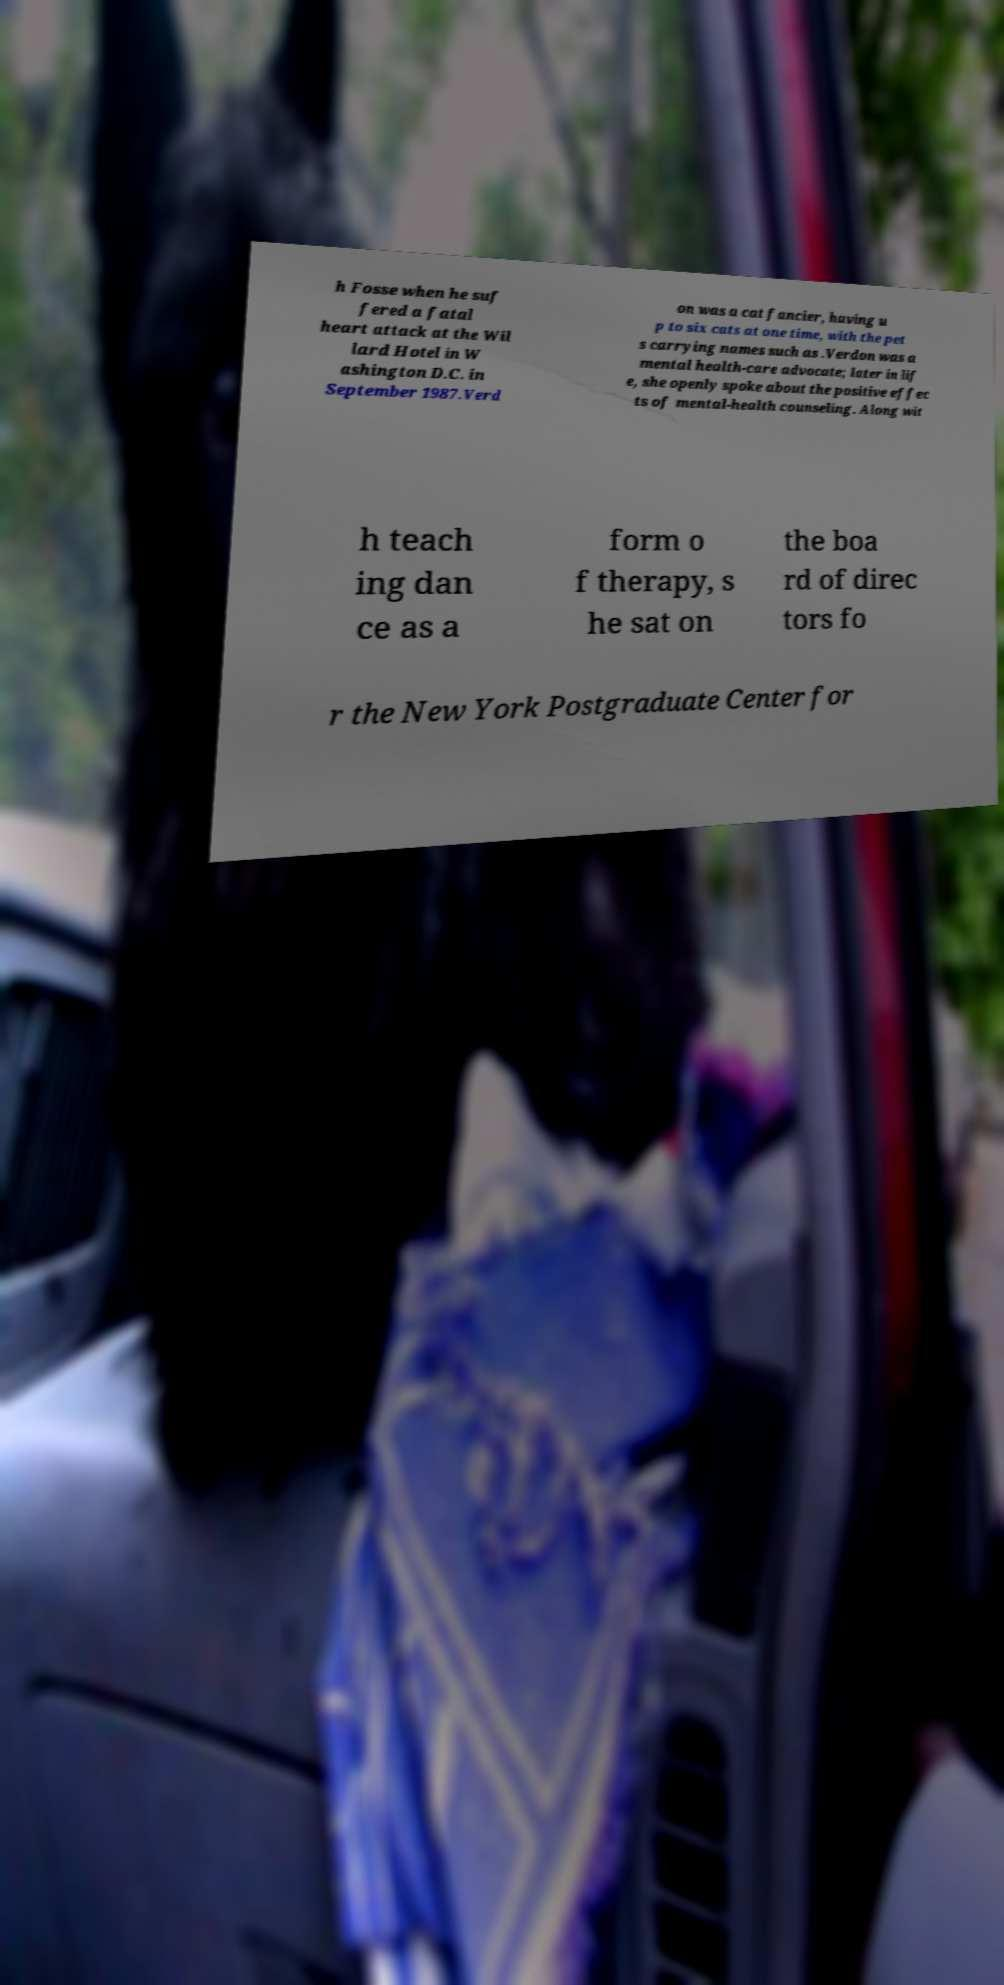I need the written content from this picture converted into text. Can you do that? h Fosse when he suf fered a fatal heart attack at the Wil lard Hotel in W ashington D.C. in September 1987.Verd on was a cat fancier, having u p to six cats at one time, with the pet s carrying names such as .Verdon was a mental health-care advocate; later in lif e, she openly spoke about the positive effec ts of mental-health counseling. Along wit h teach ing dan ce as a form o f therapy, s he sat on the boa rd of direc tors fo r the New York Postgraduate Center for 